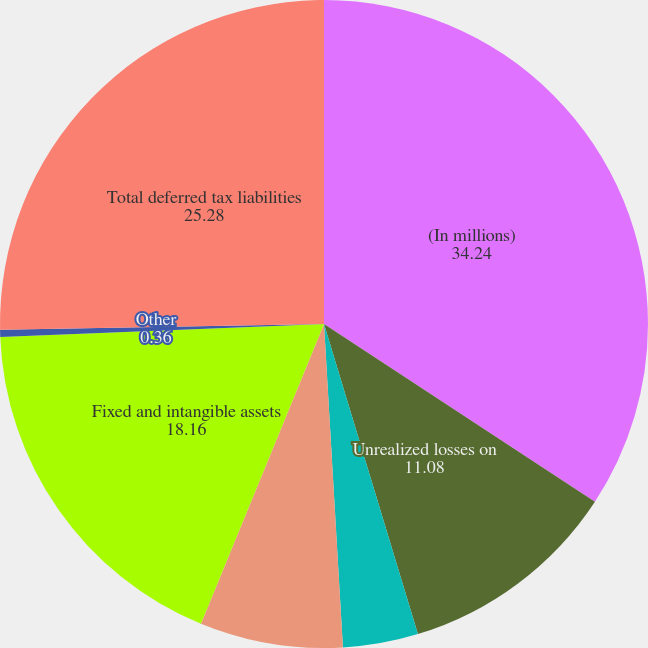<chart> <loc_0><loc_0><loc_500><loc_500><pie_chart><fcel>(In millions)<fcel>Unrealized losses on<fcel>Deferred compensation<fcel>Leveraged lease financing<fcel>Fixed and intangible assets<fcel>Other<fcel>Total deferred tax liabilities<nl><fcel>34.24%<fcel>11.08%<fcel>3.75%<fcel>7.13%<fcel>18.16%<fcel>0.36%<fcel>25.28%<nl></chart> 